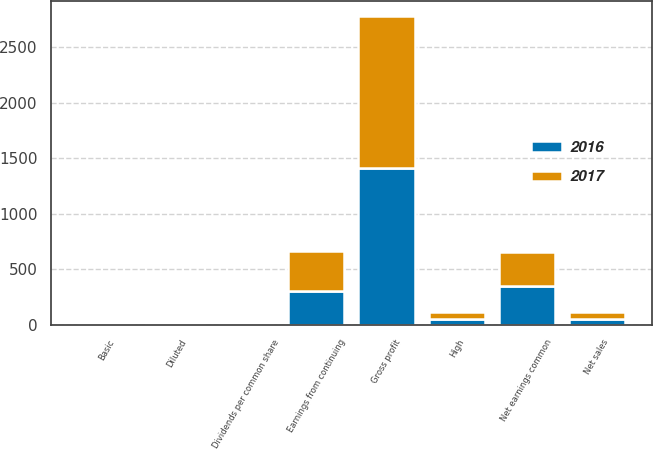Convert chart to OTSL. <chart><loc_0><loc_0><loc_500><loc_500><stacked_bar_chart><ecel><fcel>Net sales<fcel>Gross profit<fcel>Earnings from continuing<fcel>Net earnings common<fcel>Basic<fcel>Diluted<fcel>Dividends per common share<fcel>High<nl><fcel>2016<fcel>54.875<fcel>1414<fcel>303<fcel>349<fcel>0.47<fcel>0.46<fcel>0.47<fcel>51.47<nl><fcel>2017<fcel>54.875<fcel>1365<fcel>364<fcel>309<fcel>0.56<fcel>0.56<fcel>0.48<fcel>58.28<nl></chart> 